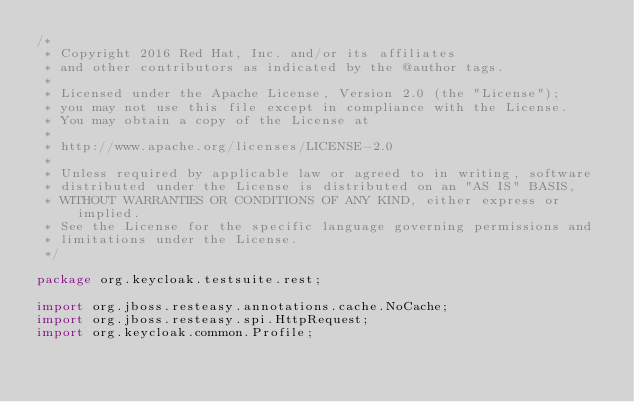<code> <loc_0><loc_0><loc_500><loc_500><_Java_>/*
 * Copyright 2016 Red Hat, Inc. and/or its affiliates
 * and other contributors as indicated by the @author tags.
 *
 * Licensed under the Apache License, Version 2.0 (the "License");
 * you may not use this file except in compliance with the License.
 * You may obtain a copy of the License at
 *
 * http://www.apache.org/licenses/LICENSE-2.0
 *
 * Unless required by applicable law or agreed to in writing, software
 * distributed under the License is distributed on an "AS IS" BASIS,
 * WITHOUT WARRANTIES OR CONDITIONS OF ANY KIND, either express or implied.
 * See the License for the specific language governing permissions and
 * limitations under the License.
 */

package org.keycloak.testsuite.rest;

import org.jboss.resteasy.annotations.cache.NoCache;
import org.jboss.resteasy.spi.HttpRequest;
import org.keycloak.common.Profile;</code> 